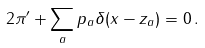Convert formula to latex. <formula><loc_0><loc_0><loc_500><loc_500>2 \pi ^ { \prime } + \sum _ { a } p _ { a } \delta ( x - z _ { a } ) = 0 \, .</formula> 